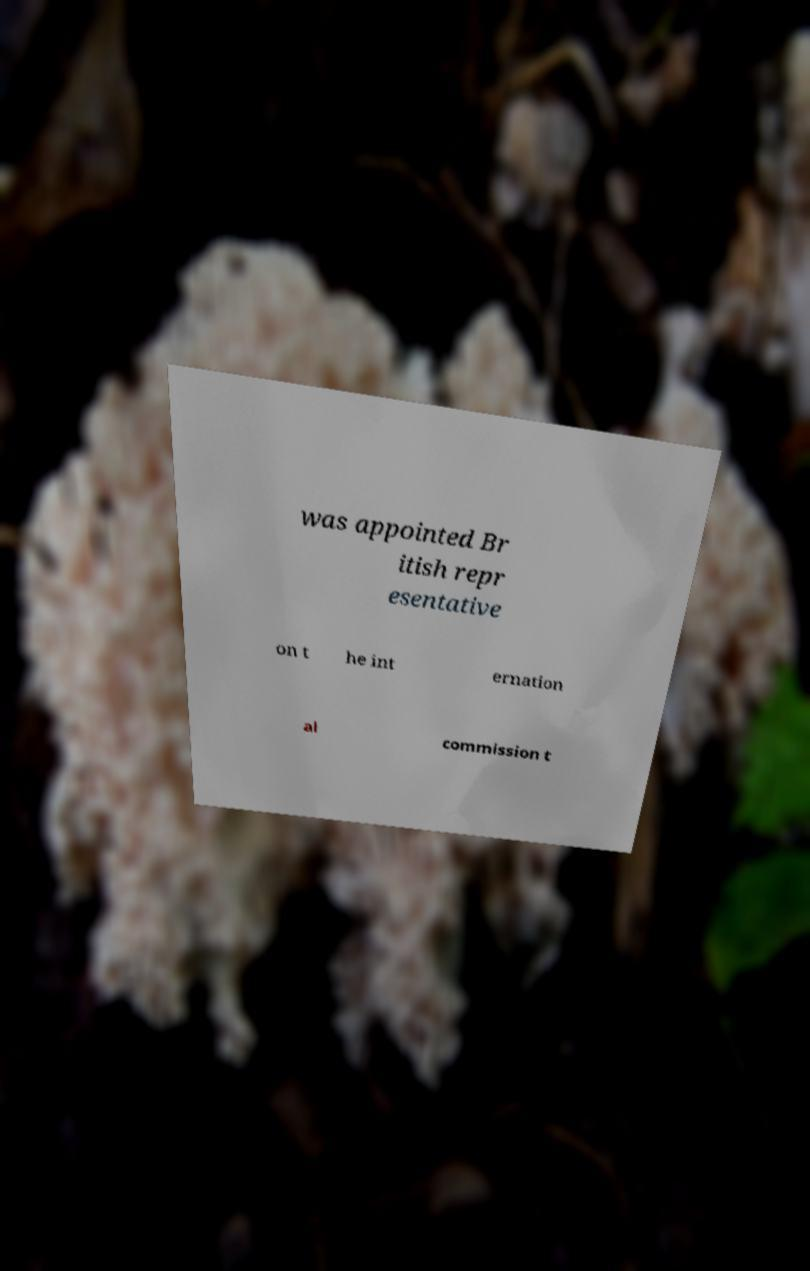What messages or text are displayed in this image? I need them in a readable, typed format. was appointed Br itish repr esentative on t he int ernation al commission t 